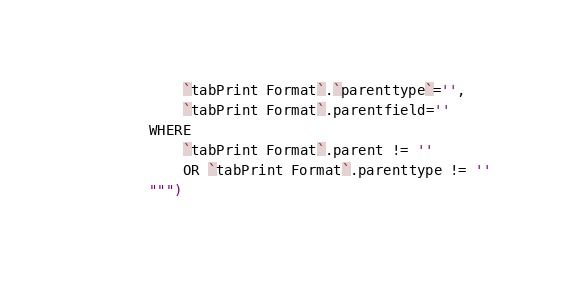Convert code to text. <code><loc_0><loc_0><loc_500><loc_500><_Python_>            `tabPrint Format`.`parenttype`='',
            `tabPrint Format`.parentfield=''
        WHERE
            `tabPrint Format`.parent != ''
            OR `tabPrint Format`.parenttype != ''
        """)</code> 